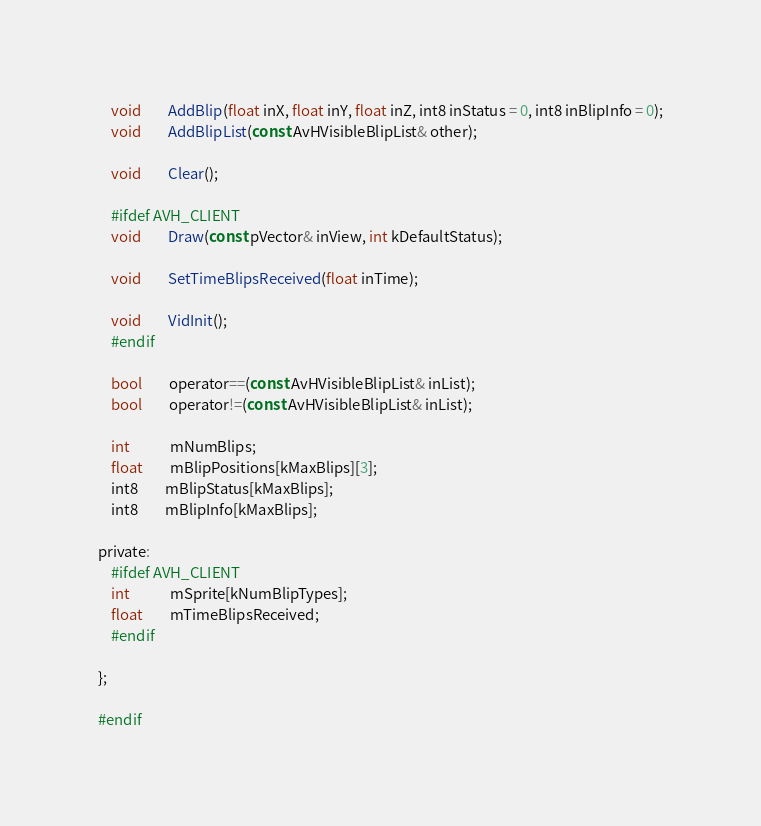<code> <loc_0><loc_0><loc_500><loc_500><_C_>	void		AddBlip(float inX, float inY, float inZ, int8 inStatus = 0, int8 inBlipInfo = 0);
	void		AddBlipList(const AvHVisibleBlipList& other);

	void		Clear();

	#ifdef AVH_CLIENT
	void		Draw(const pVector& inView, int kDefaultStatus);
				
	void		SetTimeBlipsReceived(float inTime);

	void		VidInit();
	#endif

	bool		operator==(const AvHVisibleBlipList& inList);
	bool		operator!=(const AvHVisibleBlipList& inList);
	
	int			mNumBlips;
	float		mBlipPositions[kMaxBlips][3];
	int8		mBlipStatus[kMaxBlips];
	int8		mBlipInfo[kMaxBlips];

private:
	#ifdef AVH_CLIENT
	int			mSprite[kNumBlipTypes];
	float		mTimeBlipsReceived;
	#endif

};

#endif</code> 